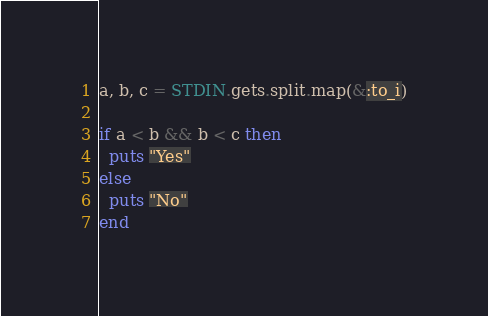<code> <loc_0><loc_0><loc_500><loc_500><_Ruby_>a, b, c = STDIN.gets.split.map(&:to_i)

if a < b && b < c then
  puts "Yes"
else
  puts "No"
end</code> 